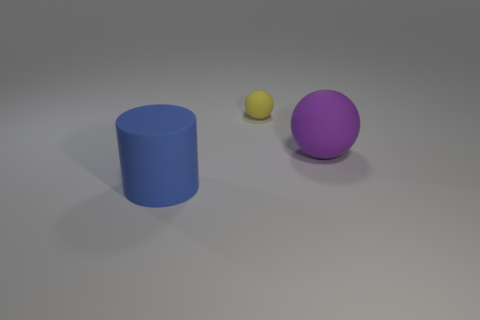Are there any other things that have the same size as the yellow rubber thing?
Offer a terse response. No. Is there a large cylinder that has the same material as the big purple thing?
Provide a succinct answer. Yes. There is a large thing left of the rubber thing that is behind the matte object to the right of the small yellow rubber ball; what color is it?
Give a very brief answer. Blue. How many purple things are cylinders or large balls?
Your answer should be very brief. 1. What number of purple matte things have the same shape as the tiny yellow object?
Make the answer very short. 1. There is a purple matte thing that is the same size as the rubber cylinder; what is its shape?
Offer a terse response. Sphere. There is a blue matte object; are there any tiny yellow rubber balls to the right of it?
Your answer should be compact. Yes. Is there a tiny yellow rubber thing to the left of the sphere that is in front of the tiny yellow rubber sphere?
Your answer should be very brief. Yes. Is the number of small rubber objects in front of the yellow matte thing less than the number of things that are behind the big purple thing?
Your answer should be compact. Yes. The large purple object is what shape?
Your answer should be compact. Sphere. 